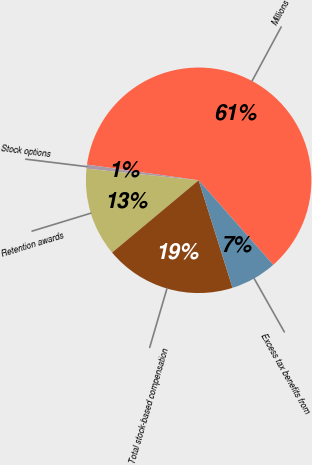Convert chart. <chart><loc_0><loc_0><loc_500><loc_500><pie_chart><fcel>Millions<fcel>Stock options<fcel>Retention awards<fcel>Total stock-based compensation<fcel>Excess tax benefits from<nl><fcel>61.27%<fcel>0.58%<fcel>12.72%<fcel>18.79%<fcel>6.65%<nl></chart> 